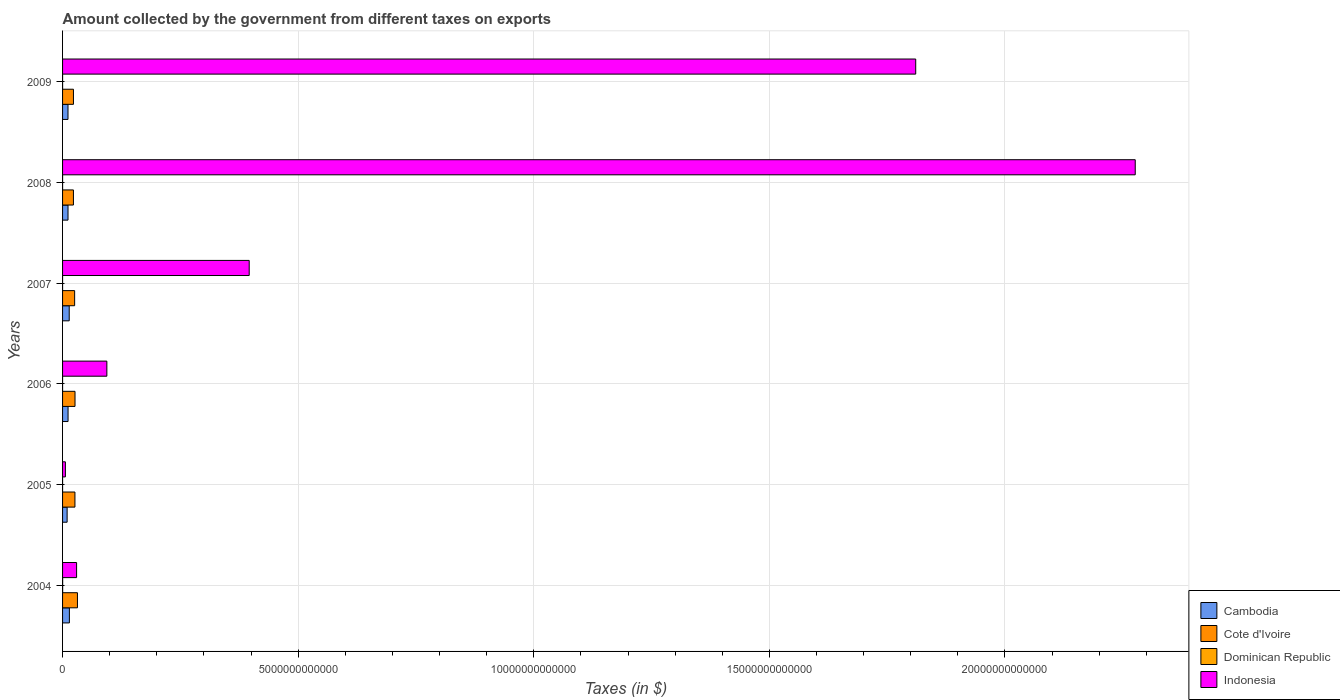Are the number of bars on each tick of the Y-axis equal?
Ensure brevity in your answer.  Yes. What is the amount collected by the government from taxes on exports in Indonesia in 2009?
Your answer should be very brief. 1.81e+13. Across all years, what is the maximum amount collected by the government from taxes on exports in Cambodia?
Your answer should be very brief. 1.45e+11. Across all years, what is the minimum amount collected by the government from taxes on exports in Dominican Republic?
Your answer should be compact. 1.36e+07. In which year was the amount collected by the government from taxes on exports in Cambodia maximum?
Make the answer very short. 2004. In which year was the amount collected by the government from taxes on exports in Dominican Republic minimum?
Make the answer very short. 2005. What is the total amount collected by the government from taxes on exports in Indonesia in the graph?
Offer a terse response. 4.61e+13. What is the difference between the amount collected by the government from taxes on exports in Cote d'Ivoire in 2004 and that in 2006?
Your answer should be very brief. 5.17e+1. What is the difference between the amount collected by the government from taxes on exports in Cote d'Ivoire in 2006 and the amount collected by the government from taxes on exports in Indonesia in 2009?
Give a very brief answer. -1.78e+13. What is the average amount collected by the government from taxes on exports in Indonesia per year?
Keep it short and to the point. 7.69e+12. In the year 2006, what is the difference between the amount collected by the government from taxes on exports in Indonesia and amount collected by the government from taxes on exports in Cote d'Ivoire?
Your response must be concise. 6.76e+11. In how many years, is the amount collected by the government from taxes on exports in Cote d'Ivoire greater than 8000000000000 $?
Make the answer very short. 0. What is the ratio of the amount collected by the government from taxes on exports in Indonesia in 2006 to that in 2009?
Your response must be concise. 0.05. Is the amount collected by the government from taxes on exports in Cote d'Ivoire in 2007 less than that in 2009?
Offer a terse response. No. Is the difference between the amount collected by the government from taxes on exports in Indonesia in 2008 and 2009 greater than the difference between the amount collected by the government from taxes on exports in Cote d'Ivoire in 2008 and 2009?
Your response must be concise. Yes. What is the difference between the highest and the second highest amount collected by the government from taxes on exports in Cote d'Ivoire?
Offer a very short reply. 5.17e+1. What is the difference between the highest and the lowest amount collected by the government from taxes on exports in Cote d'Ivoire?
Provide a succinct answer. 8.52e+1. In how many years, is the amount collected by the government from taxes on exports in Cote d'Ivoire greater than the average amount collected by the government from taxes on exports in Cote d'Ivoire taken over all years?
Provide a succinct answer. 3. What does the 4th bar from the top in 2009 represents?
Your answer should be very brief. Cambodia. What does the 3rd bar from the bottom in 2005 represents?
Your answer should be compact. Dominican Republic. How many years are there in the graph?
Your answer should be very brief. 6. What is the difference between two consecutive major ticks on the X-axis?
Your response must be concise. 5.00e+12. Are the values on the major ticks of X-axis written in scientific E-notation?
Your response must be concise. No. Does the graph contain any zero values?
Give a very brief answer. No. Does the graph contain grids?
Offer a terse response. Yes. Where does the legend appear in the graph?
Provide a succinct answer. Bottom right. How many legend labels are there?
Make the answer very short. 4. How are the legend labels stacked?
Keep it short and to the point. Vertical. What is the title of the graph?
Offer a terse response. Amount collected by the government from different taxes on exports. What is the label or title of the X-axis?
Ensure brevity in your answer.  Taxes (in $). What is the label or title of the Y-axis?
Your answer should be very brief. Years. What is the Taxes (in $) in Cambodia in 2004?
Your response must be concise. 1.45e+11. What is the Taxes (in $) in Cote d'Ivoire in 2004?
Offer a terse response. 3.16e+11. What is the Taxes (in $) in Dominican Republic in 2004?
Offer a very short reply. 1.71e+09. What is the Taxes (in $) of Indonesia in 2004?
Your answer should be very brief. 2.98e+11. What is the Taxes (in $) of Cambodia in 2005?
Offer a terse response. 9.67e+1. What is the Taxes (in $) in Cote d'Ivoire in 2005?
Offer a terse response. 2.63e+11. What is the Taxes (in $) of Dominican Republic in 2005?
Make the answer very short. 1.36e+07. What is the Taxes (in $) of Indonesia in 2005?
Provide a succinct answer. 6.00e+1. What is the Taxes (in $) in Cambodia in 2006?
Your response must be concise. 1.17e+11. What is the Taxes (in $) of Cote d'Ivoire in 2006?
Ensure brevity in your answer.  2.64e+11. What is the Taxes (in $) in Dominican Republic in 2006?
Offer a terse response. 6.90e+07. What is the Taxes (in $) of Indonesia in 2006?
Offer a very short reply. 9.40e+11. What is the Taxes (in $) of Cambodia in 2007?
Offer a very short reply. 1.41e+11. What is the Taxes (in $) of Cote d'Ivoire in 2007?
Ensure brevity in your answer.  2.56e+11. What is the Taxes (in $) in Dominican Republic in 2007?
Offer a terse response. 8.25e+07. What is the Taxes (in $) in Indonesia in 2007?
Make the answer very short. 3.96e+12. What is the Taxes (in $) of Cambodia in 2008?
Offer a terse response. 1.16e+11. What is the Taxes (in $) in Cote d'Ivoire in 2008?
Give a very brief answer. 2.31e+11. What is the Taxes (in $) in Dominican Republic in 2008?
Your answer should be very brief. 1.28e+08. What is the Taxes (in $) in Indonesia in 2008?
Offer a terse response. 2.28e+13. What is the Taxes (in $) of Cambodia in 2009?
Your answer should be very brief. 1.15e+11. What is the Taxes (in $) in Cote d'Ivoire in 2009?
Provide a succinct answer. 2.31e+11. What is the Taxes (in $) of Dominican Republic in 2009?
Ensure brevity in your answer.  1.32e+08. What is the Taxes (in $) of Indonesia in 2009?
Ensure brevity in your answer.  1.81e+13. Across all years, what is the maximum Taxes (in $) of Cambodia?
Offer a terse response. 1.45e+11. Across all years, what is the maximum Taxes (in $) of Cote d'Ivoire?
Provide a succinct answer. 3.16e+11. Across all years, what is the maximum Taxes (in $) in Dominican Republic?
Make the answer very short. 1.71e+09. Across all years, what is the maximum Taxes (in $) of Indonesia?
Ensure brevity in your answer.  2.28e+13. Across all years, what is the minimum Taxes (in $) in Cambodia?
Give a very brief answer. 9.67e+1. Across all years, what is the minimum Taxes (in $) of Cote d'Ivoire?
Your response must be concise. 2.31e+11. Across all years, what is the minimum Taxes (in $) of Dominican Republic?
Provide a succinct answer. 1.36e+07. Across all years, what is the minimum Taxes (in $) of Indonesia?
Make the answer very short. 6.00e+1. What is the total Taxes (in $) of Cambodia in the graph?
Provide a short and direct response. 7.30e+11. What is the total Taxes (in $) in Cote d'Ivoire in the graph?
Your answer should be compact. 1.56e+12. What is the total Taxes (in $) in Dominican Republic in the graph?
Keep it short and to the point. 2.13e+09. What is the total Taxes (in $) of Indonesia in the graph?
Your response must be concise. 4.61e+13. What is the difference between the Taxes (in $) of Cambodia in 2004 and that in 2005?
Offer a very short reply. 4.83e+1. What is the difference between the Taxes (in $) of Cote d'Ivoire in 2004 and that in 2005?
Offer a very short reply. 5.33e+1. What is the difference between the Taxes (in $) in Dominican Republic in 2004 and that in 2005?
Your response must be concise. 1.69e+09. What is the difference between the Taxes (in $) in Indonesia in 2004 and that in 2005?
Offer a terse response. 2.38e+11. What is the difference between the Taxes (in $) in Cambodia in 2004 and that in 2006?
Make the answer very short. 2.83e+1. What is the difference between the Taxes (in $) in Cote d'Ivoire in 2004 and that in 2006?
Ensure brevity in your answer.  5.17e+1. What is the difference between the Taxes (in $) of Dominican Republic in 2004 and that in 2006?
Offer a terse response. 1.64e+09. What is the difference between the Taxes (in $) of Indonesia in 2004 and that in 2006?
Offer a very short reply. -6.42e+11. What is the difference between the Taxes (in $) of Cambodia in 2004 and that in 2007?
Your answer should be very brief. 3.83e+09. What is the difference between the Taxes (in $) of Cote d'Ivoire in 2004 and that in 2007?
Make the answer very short. 5.99e+1. What is the difference between the Taxes (in $) of Dominican Republic in 2004 and that in 2007?
Offer a terse response. 1.62e+09. What is the difference between the Taxes (in $) of Indonesia in 2004 and that in 2007?
Your answer should be compact. -3.66e+12. What is the difference between the Taxes (in $) in Cambodia in 2004 and that in 2008?
Offer a terse response. 2.93e+1. What is the difference between the Taxes (in $) in Cote d'Ivoire in 2004 and that in 2008?
Make the answer very short. 8.52e+1. What is the difference between the Taxes (in $) in Dominican Republic in 2004 and that in 2008?
Ensure brevity in your answer.  1.58e+09. What is the difference between the Taxes (in $) of Indonesia in 2004 and that in 2008?
Your response must be concise. -2.25e+13. What is the difference between the Taxes (in $) of Cambodia in 2004 and that in 2009?
Your answer should be very brief. 2.96e+1. What is the difference between the Taxes (in $) of Cote d'Ivoire in 2004 and that in 2009?
Your response must be concise. 8.48e+1. What is the difference between the Taxes (in $) in Dominican Republic in 2004 and that in 2009?
Keep it short and to the point. 1.57e+09. What is the difference between the Taxes (in $) in Indonesia in 2004 and that in 2009?
Offer a very short reply. -1.78e+13. What is the difference between the Taxes (in $) in Cambodia in 2005 and that in 2006?
Keep it short and to the point. -1.99e+1. What is the difference between the Taxes (in $) in Cote d'Ivoire in 2005 and that in 2006?
Ensure brevity in your answer.  -1.60e+09. What is the difference between the Taxes (in $) in Dominican Republic in 2005 and that in 2006?
Your answer should be compact. -5.54e+07. What is the difference between the Taxes (in $) of Indonesia in 2005 and that in 2006?
Your answer should be very brief. -8.80e+11. What is the difference between the Taxes (in $) of Cambodia in 2005 and that in 2007?
Offer a very short reply. -4.44e+1. What is the difference between the Taxes (in $) of Cote d'Ivoire in 2005 and that in 2007?
Provide a succinct answer. 6.60e+09. What is the difference between the Taxes (in $) of Dominican Republic in 2005 and that in 2007?
Offer a terse response. -6.89e+07. What is the difference between the Taxes (in $) of Indonesia in 2005 and that in 2007?
Your response must be concise. -3.90e+12. What is the difference between the Taxes (in $) in Cambodia in 2005 and that in 2008?
Keep it short and to the point. -1.89e+1. What is the difference between the Taxes (in $) of Cote d'Ivoire in 2005 and that in 2008?
Provide a short and direct response. 3.19e+1. What is the difference between the Taxes (in $) of Dominican Republic in 2005 and that in 2008?
Your answer should be very brief. -1.15e+08. What is the difference between the Taxes (in $) of Indonesia in 2005 and that in 2008?
Provide a succinct answer. -2.27e+13. What is the difference between the Taxes (in $) of Cambodia in 2005 and that in 2009?
Keep it short and to the point. -1.86e+1. What is the difference between the Taxes (in $) in Cote d'Ivoire in 2005 and that in 2009?
Ensure brevity in your answer.  3.15e+1. What is the difference between the Taxes (in $) of Dominican Republic in 2005 and that in 2009?
Provide a short and direct response. -1.18e+08. What is the difference between the Taxes (in $) of Indonesia in 2005 and that in 2009?
Give a very brief answer. -1.80e+13. What is the difference between the Taxes (in $) in Cambodia in 2006 and that in 2007?
Ensure brevity in your answer.  -2.45e+1. What is the difference between the Taxes (in $) in Cote d'Ivoire in 2006 and that in 2007?
Keep it short and to the point. 8.20e+09. What is the difference between the Taxes (in $) of Dominican Republic in 2006 and that in 2007?
Keep it short and to the point. -1.35e+07. What is the difference between the Taxes (in $) of Indonesia in 2006 and that in 2007?
Your answer should be compact. -3.02e+12. What is the difference between the Taxes (in $) of Cambodia in 2006 and that in 2008?
Keep it short and to the point. 1.02e+09. What is the difference between the Taxes (in $) in Cote d'Ivoire in 2006 and that in 2008?
Your response must be concise. 3.35e+1. What is the difference between the Taxes (in $) in Dominican Republic in 2006 and that in 2008?
Provide a succinct answer. -5.92e+07. What is the difference between the Taxes (in $) of Indonesia in 2006 and that in 2008?
Make the answer very short. -2.18e+13. What is the difference between the Taxes (in $) in Cambodia in 2006 and that in 2009?
Make the answer very short. 1.31e+09. What is the difference between the Taxes (in $) in Cote d'Ivoire in 2006 and that in 2009?
Provide a succinct answer. 3.31e+1. What is the difference between the Taxes (in $) of Dominican Republic in 2006 and that in 2009?
Offer a very short reply. -6.27e+07. What is the difference between the Taxes (in $) in Indonesia in 2006 and that in 2009?
Your answer should be very brief. -1.72e+13. What is the difference between the Taxes (in $) of Cambodia in 2007 and that in 2008?
Keep it short and to the point. 2.55e+1. What is the difference between the Taxes (in $) of Cote d'Ivoire in 2007 and that in 2008?
Make the answer very short. 2.53e+1. What is the difference between the Taxes (in $) of Dominican Republic in 2007 and that in 2008?
Your answer should be very brief. -4.56e+07. What is the difference between the Taxes (in $) of Indonesia in 2007 and that in 2008?
Give a very brief answer. -1.88e+13. What is the difference between the Taxes (in $) of Cambodia in 2007 and that in 2009?
Give a very brief answer. 2.58e+1. What is the difference between the Taxes (in $) of Cote d'Ivoire in 2007 and that in 2009?
Offer a terse response. 2.49e+1. What is the difference between the Taxes (in $) in Dominican Republic in 2007 and that in 2009?
Your response must be concise. -4.92e+07. What is the difference between the Taxes (in $) in Indonesia in 2007 and that in 2009?
Provide a short and direct response. -1.41e+13. What is the difference between the Taxes (in $) of Cambodia in 2008 and that in 2009?
Give a very brief answer. 2.95e+08. What is the difference between the Taxes (in $) in Cote d'Ivoire in 2008 and that in 2009?
Your answer should be very brief. -4.00e+08. What is the difference between the Taxes (in $) in Dominican Republic in 2008 and that in 2009?
Make the answer very short. -3.52e+06. What is the difference between the Taxes (in $) in Indonesia in 2008 and that in 2009?
Your answer should be very brief. 4.66e+12. What is the difference between the Taxes (in $) in Cambodia in 2004 and the Taxes (in $) in Cote d'Ivoire in 2005?
Provide a succinct answer. -1.18e+11. What is the difference between the Taxes (in $) in Cambodia in 2004 and the Taxes (in $) in Dominican Republic in 2005?
Keep it short and to the point. 1.45e+11. What is the difference between the Taxes (in $) in Cambodia in 2004 and the Taxes (in $) in Indonesia in 2005?
Offer a very short reply. 8.49e+1. What is the difference between the Taxes (in $) in Cote d'Ivoire in 2004 and the Taxes (in $) in Dominican Republic in 2005?
Keep it short and to the point. 3.16e+11. What is the difference between the Taxes (in $) in Cote d'Ivoire in 2004 and the Taxes (in $) in Indonesia in 2005?
Offer a very short reply. 2.56e+11. What is the difference between the Taxes (in $) in Dominican Republic in 2004 and the Taxes (in $) in Indonesia in 2005?
Offer a very short reply. -5.83e+1. What is the difference between the Taxes (in $) of Cambodia in 2004 and the Taxes (in $) of Cote d'Ivoire in 2006?
Your answer should be very brief. -1.19e+11. What is the difference between the Taxes (in $) of Cambodia in 2004 and the Taxes (in $) of Dominican Republic in 2006?
Your response must be concise. 1.45e+11. What is the difference between the Taxes (in $) in Cambodia in 2004 and the Taxes (in $) in Indonesia in 2006?
Ensure brevity in your answer.  -7.95e+11. What is the difference between the Taxes (in $) in Cote d'Ivoire in 2004 and the Taxes (in $) in Dominican Republic in 2006?
Offer a terse response. 3.16e+11. What is the difference between the Taxes (in $) in Cote d'Ivoire in 2004 and the Taxes (in $) in Indonesia in 2006?
Your answer should be compact. -6.24e+11. What is the difference between the Taxes (in $) of Dominican Republic in 2004 and the Taxes (in $) of Indonesia in 2006?
Your response must be concise. -9.38e+11. What is the difference between the Taxes (in $) in Cambodia in 2004 and the Taxes (in $) in Cote d'Ivoire in 2007?
Ensure brevity in your answer.  -1.11e+11. What is the difference between the Taxes (in $) of Cambodia in 2004 and the Taxes (in $) of Dominican Republic in 2007?
Your answer should be compact. 1.45e+11. What is the difference between the Taxes (in $) in Cambodia in 2004 and the Taxes (in $) in Indonesia in 2007?
Offer a very short reply. -3.82e+12. What is the difference between the Taxes (in $) in Cote d'Ivoire in 2004 and the Taxes (in $) in Dominican Republic in 2007?
Keep it short and to the point. 3.16e+11. What is the difference between the Taxes (in $) in Cote d'Ivoire in 2004 and the Taxes (in $) in Indonesia in 2007?
Ensure brevity in your answer.  -3.64e+12. What is the difference between the Taxes (in $) of Dominican Republic in 2004 and the Taxes (in $) of Indonesia in 2007?
Provide a succinct answer. -3.96e+12. What is the difference between the Taxes (in $) of Cambodia in 2004 and the Taxes (in $) of Cote d'Ivoire in 2008?
Your response must be concise. -8.59e+1. What is the difference between the Taxes (in $) of Cambodia in 2004 and the Taxes (in $) of Dominican Republic in 2008?
Your answer should be compact. 1.45e+11. What is the difference between the Taxes (in $) of Cambodia in 2004 and the Taxes (in $) of Indonesia in 2008?
Offer a terse response. -2.26e+13. What is the difference between the Taxes (in $) of Cote d'Ivoire in 2004 and the Taxes (in $) of Dominican Republic in 2008?
Make the answer very short. 3.16e+11. What is the difference between the Taxes (in $) of Cote d'Ivoire in 2004 and the Taxes (in $) of Indonesia in 2008?
Provide a succinct answer. -2.24e+13. What is the difference between the Taxes (in $) of Dominican Republic in 2004 and the Taxes (in $) of Indonesia in 2008?
Your answer should be very brief. -2.28e+13. What is the difference between the Taxes (in $) in Cambodia in 2004 and the Taxes (in $) in Cote d'Ivoire in 2009?
Give a very brief answer. -8.63e+1. What is the difference between the Taxes (in $) of Cambodia in 2004 and the Taxes (in $) of Dominican Republic in 2009?
Make the answer very short. 1.45e+11. What is the difference between the Taxes (in $) of Cambodia in 2004 and the Taxes (in $) of Indonesia in 2009?
Keep it short and to the point. -1.80e+13. What is the difference between the Taxes (in $) in Cote d'Ivoire in 2004 and the Taxes (in $) in Dominican Republic in 2009?
Your response must be concise. 3.16e+11. What is the difference between the Taxes (in $) of Cote d'Ivoire in 2004 and the Taxes (in $) of Indonesia in 2009?
Ensure brevity in your answer.  -1.78e+13. What is the difference between the Taxes (in $) of Dominican Republic in 2004 and the Taxes (in $) of Indonesia in 2009?
Provide a succinct answer. -1.81e+13. What is the difference between the Taxes (in $) of Cambodia in 2005 and the Taxes (in $) of Cote d'Ivoire in 2006?
Your answer should be very brief. -1.68e+11. What is the difference between the Taxes (in $) in Cambodia in 2005 and the Taxes (in $) in Dominican Republic in 2006?
Give a very brief answer. 9.66e+1. What is the difference between the Taxes (in $) in Cambodia in 2005 and the Taxes (in $) in Indonesia in 2006?
Your answer should be compact. -8.43e+11. What is the difference between the Taxes (in $) in Cote d'Ivoire in 2005 and the Taxes (in $) in Dominican Republic in 2006?
Give a very brief answer. 2.63e+11. What is the difference between the Taxes (in $) of Cote d'Ivoire in 2005 and the Taxes (in $) of Indonesia in 2006?
Offer a very short reply. -6.77e+11. What is the difference between the Taxes (in $) of Dominican Republic in 2005 and the Taxes (in $) of Indonesia in 2006?
Keep it short and to the point. -9.40e+11. What is the difference between the Taxes (in $) in Cambodia in 2005 and the Taxes (in $) in Cote d'Ivoire in 2007?
Make the answer very short. -1.59e+11. What is the difference between the Taxes (in $) in Cambodia in 2005 and the Taxes (in $) in Dominican Republic in 2007?
Provide a short and direct response. 9.66e+1. What is the difference between the Taxes (in $) of Cambodia in 2005 and the Taxes (in $) of Indonesia in 2007?
Provide a succinct answer. -3.86e+12. What is the difference between the Taxes (in $) in Cote d'Ivoire in 2005 and the Taxes (in $) in Dominican Republic in 2007?
Provide a short and direct response. 2.63e+11. What is the difference between the Taxes (in $) in Cote d'Ivoire in 2005 and the Taxes (in $) in Indonesia in 2007?
Your answer should be very brief. -3.70e+12. What is the difference between the Taxes (in $) in Dominican Republic in 2005 and the Taxes (in $) in Indonesia in 2007?
Offer a very short reply. -3.96e+12. What is the difference between the Taxes (in $) of Cambodia in 2005 and the Taxes (in $) of Cote d'Ivoire in 2008?
Your answer should be very brief. -1.34e+11. What is the difference between the Taxes (in $) of Cambodia in 2005 and the Taxes (in $) of Dominican Republic in 2008?
Offer a very short reply. 9.66e+1. What is the difference between the Taxes (in $) of Cambodia in 2005 and the Taxes (in $) of Indonesia in 2008?
Make the answer very short. -2.27e+13. What is the difference between the Taxes (in $) of Cote d'Ivoire in 2005 and the Taxes (in $) of Dominican Republic in 2008?
Keep it short and to the point. 2.63e+11. What is the difference between the Taxes (in $) in Cote d'Ivoire in 2005 and the Taxes (in $) in Indonesia in 2008?
Keep it short and to the point. -2.25e+13. What is the difference between the Taxes (in $) in Dominican Republic in 2005 and the Taxes (in $) in Indonesia in 2008?
Provide a short and direct response. -2.28e+13. What is the difference between the Taxes (in $) of Cambodia in 2005 and the Taxes (in $) of Cote d'Ivoire in 2009?
Keep it short and to the point. -1.35e+11. What is the difference between the Taxes (in $) in Cambodia in 2005 and the Taxes (in $) in Dominican Republic in 2009?
Offer a terse response. 9.66e+1. What is the difference between the Taxes (in $) in Cambodia in 2005 and the Taxes (in $) in Indonesia in 2009?
Give a very brief answer. -1.80e+13. What is the difference between the Taxes (in $) of Cote d'Ivoire in 2005 and the Taxes (in $) of Dominican Republic in 2009?
Make the answer very short. 2.63e+11. What is the difference between the Taxes (in $) of Cote d'Ivoire in 2005 and the Taxes (in $) of Indonesia in 2009?
Give a very brief answer. -1.78e+13. What is the difference between the Taxes (in $) of Dominican Republic in 2005 and the Taxes (in $) of Indonesia in 2009?
Your response must be concise. -1.81e+13. What is the difference between the Taxes (in $) of Cambodia in 2006 and the Taxes (in $) of Cote d'Ivoire in 2007?
Make the answer very short. -1.39e+11. What is the difference between the Taxes (in $) in Cambodia in 2006 and the Taxes (in $) in Dominican Republic in 2007?
Make the answer very short. 1.17e+11. What is the difference between the Taxes (in $) in Cambodia in 2006 and the Taxes (in $) in Indonesia in 2007?
Ensure brevity in your answer.  -3.84e+12. What is the difference between the Taxes (in $) of Cote d'Ivoire in 2006 and the Taxes (in $) of Dominican Republic in 2007?
Provide a succinct answer. 2.64e+11. What is the difference between the Taxes (in $) of Cote d'Ivoire in 2006 and the Taxes (in $) of Indonesia in 2007?
Provide a short and direct response. -3.70e+12. What is the difference between the Taxes (in $) of Dominican Republic in 2006 and the Taxes (in $) of Indonesia in 2007?
Offer a very short reply. -3.96e+12. What is the difference between the Taxes (in $) of Cambodia in 2006 and the Taxes (in $) of Cote d'Ivoire in 2008?
Your response must be concise. -1.14e+11. What is the difference between the Taxes (in $) of Cambodia in 2006 and the Taxes (in $) of Dominican Republic in 2008?
Your answer should be very brief. 1.17e+11. What is the difference between the Taxes (in $) in Cambodia in 2006 and the Taxes (in $) in Indonesia in 2008?
Keep it short and to the point. -2.26e+13. What is the difference between the Taxes (in $) in Cote d'Ivoire in 2006 and the Taxes (in $) in Dominican Republic in 2008?
Offer a terse response. 2.64e+11. What is the difference between the Taxes (in $) in Cote d'Ivoire in 2006 and the Taxes (in $) in Indonesia in 2008?
Give a very brief answer. -2.25e+13. What is the difference between the Taxes (in $) of Dominican Republic in 2006 and the Taxes (in $) of Indonesia in 2008?
Provide a succinct answer. -2.28e+13. What is the difference between the Taxes (in $) in Cambodia in 2006 and the Taxes (in $) in Cote d'Ivoire in 2009?
Your answer should be very brief. -1.15e+11. What is the difference between the Taxes (in $) of Cambodia in 2006 and the Taxes (in $) of Dominican Republic in 2009?
Ensure brevity in your answer.  1.17e+11. What is the difference between the Taxes (in $) in Cambodia in 2006 and the Taxes (in $) in Indonesia in 2009?
Your answer should be very brief. -1.80e+13. What is the difference between the Taxes (in $) in Cote d'Ivoire in 2006 and the Taxes (in $) in Dominican Republic in 2009?
Ensure brevity in your answer.  2.64e+11. What is the difference between the Taxes (in $) in Cote d'Ivoire in 2006 and the Taxes (in $) in Indonesia in 2009?
Your answer should be compact. -1.78e+13. What is the difference between the Taxes (in $) of Dominican Republic in 2006 and the Taxes (in $) of Indonesia in 2009?
Make the answer very short. -1.81e+13. What is the difference between the Taxes (in $) of Cambodia in 2007 and the Taxes (in $) of Cote d'Ivoire in 2008?
Offer a terse response. -8.97e+1. What is the difference between the Taxes (in $) of Cambodia in 2007 and the Taxes (in $) of Dominican Republic in 2008?
Offer a very short reply. 1.41e+11. What is the difference between the Taxes (in $) of Cambodia in 2007 and the Taxes (in $) of Indonesia in 2008?
Provide a short and direct response. -2.26e+13. What is the difference between the Taxes (in $) of Cote d'Ivoire in 2007 and the Taxes (in $) of Dominican Republic in 2008?
Ensure brevity in your answer.  2.56e+11. What is the difference between the Taxes (in $) of Cote d'Ivoire in 2007 and the Taxes (in $) of Indonesia in 2008?
Make the answer very short. -2.25e+13. What is the difference between the Taxes (in $) of Dominican Republic in 2007 and the Taxes (in $) of Indonesia in 2008?
Your response must be concise. -2.28e+13. What is the difference between the Taxes (in $) of Cambodia in 2007 and the Taxes (in $) of Cote d'Ivoire in 2009?
Make the answer very short. -9.01e+1. What is the difference between the Taxes (in $) in Cambodia in 2007 and the Taxes (in $) in Dominican Republic in 2009?
Your answer should be compact. 1.41e+11. What is the difference between the Taxes (in $) in Cambodia in 2007 and the Taxes (in $) in Indonesia in 2009?
Provide a short and direct response. -1.80e+13. What is the difference between the Taxes (in $) of Cote d'Ivoire in 2007 and the Taxes (in $) of Dominican Republic in 2009?
Provide a short and direct response. 2.56e+11. What is the difference between the Taxes (in $) in Cote d'Ivoire in 2007 and the Taxes (in $) in Indonesia in 2009?
Make the answer very short. -1.78e+13. What is the difference between the Taxes (in $) in Dominican Republic in 2007 and the Taxes (in $) in Indonesia in 2009?
Offer a terse response. -1.81e+13. What is the difference between the Taxes (in $) in Cambodia in 2008 and the Taxes (in $) in Cote d'Ivoire in 2009?
Provide a short and direct response. -1.16e+11. What is the difference between the Taxes (in $) of Cambodia in 2008 and the Taxes (in $) of Dominican Republic in 2009?
Make the answer very short. 1.15e+11. What is the difference between the Taxes (in $) in Cambodia in 2008 and the Taxes (in $) in Indonesia in 2009?
Provide a succinct answer. -1.80e+13. What is the difference between the Taxes (in $) in Cote d'Ivoire in 2008 and the Taxes (in $) in Dominican Republic in 2009?
Your answer should be compact. 2.31e+11. What is the difference between the Taxes (in $) of Cote d'Ivoire in 2008 and the Taxes (in $) of Indonesia in 2009?
Your answer should be very brief. -1.79e+13. What is the difference between the Taxes (in $) of Dominican Republic in 2008 and the Taxes (in $) of Indonesia in 2009?
Provide a succinct answer. -1.81e+13. What is the average Taxes (in $) of Cambodia per year?
Your response must be concise. 1.22e+11. What is the average Taxes (in $) in Cote d'Ivoire per year?
Offer a very short reply. 2.60e+11. What is the average Taxes (in $) of Dominican Republic per year?
Offer a very short reply. 3.55e+08. What is the average Taxes (in $) of Indonesia per year?
Offer a terse response. 7.69e+12. In the year 2004, what is the difference between the Taxes (in $) of Cambodia and Taxes (in $) of Cote d'Ivoire?
Offer a very short reply. -1.71e+11. In the year 2004, what is the difference between the Taxes (in $) of Cambodia and Taxes (in $) of Dominican Republic?
Give a very brief answer. 1.43e+11. In the year 2004, what is the difference between the Taxes (in $) in Cambodia and Taxes (in $) in Indonesia?
Your answer should be compact. -1.53e+11. In the year 2004, what is the difference between the Taxes (in $) in Cote d'Ivoire and Taxes (in $) in Dominican Republic?
Your answer should be compact. 3.14e+11. In the year 2004, what is the difference between the Taxes (in $) of Cote d'Ivoire and Taxes (in $) of Indonesia?
Your response must be concise. 1.82e+1. In the year 2004, what is the difference between the Taxes (in $) of Dominican Republic and Taxes (in $) of Indonesia?
Make the answer very short. -2.96e+11. In the year 2005, what is the difference between the Taxes (in $) of Cambodia and Taxes (in $) of Cote d'Ivoire?
Provide a succinct answer. -1.66e+11. In the year 2005, what is the difference between the Taxes (in $) in Cambodia and Taxes (in $) in Dominican Republic?
Your response must be concise. 9.67e+1. In the year 2005, what is the difference between the Taxes (in $) of Cambodia and Taxes (in $) of Indonesia?
Ensure brevity in your answer.  3.67e+1. In the year 2005, what is the difference between the Taxes (in $) of Cote d'Ivoire and Taxes (in $) of Dominican Republic?
Your response must be concise. 2.63e+11. In the year 2005, what is the difference between the Taxes (in $) of Cote d'Ivoire and Taxes (in $) of Indonesia?
Keep it short and to the point. 2.03e+11. In the year 2005, what is the difference between the Taxes (in $) of Dominican Republic and Taxes (in $) of Indonesia?
Your response must be concise. -6.00e+1. In the year 2006, what is the difference between the Taxes (in $) of Cambodia and Taxes (in $) of Cote d'Ivoire?
Offer a very short reply. -1.48e+11. In the year 2006, what is the difference between the Taxes (in $) in Cambodia and Taxes (in $) in Dominican Republic?
Provide a short and direct response. 1.17e+11. In the year 2006, what is the difference between the Taxes (in $) of Cambodia and Taxes (in $) of Indonesia?
Your answer should be very brief. -8.23e+11. In the year 2006, what is the difference between the Taxes (in $) in Cote d'Ivoire and Taxes (in $) in Dominican Republic?
Your response must be concise. 2.64e+11. In the year 2006, what is the difference between the Taxes (in $) in Cote d'Ivoire and Taxes (in $) in Indonesia?
Ensure brevity in your answer.  -6.76e+11. In the year 2006, what is the difference between the Taxes (in $) in Dominican Republic and Taxes (in $) in Indonesia?
Offer a very short reply. -9.40e+11. In the year 2007, what is the difference between the Taxes (in $) of Cambodia and Taxes (in $) of Cote d'Ivoire?
Keep it short and to the point. -1.15e+11. In the year 2007, what is the difference between the Taxes (in $) of Cambodia and Taxes (in $) of Dominican Republic?
Make the answer very short. 1.41e+11. In the year 2007, what is the difference between the Taxes (in $) of Cambodia and Taxes (in $) of Indonesia?
Ensure brevity in your answer.  -3.82e+12. In the year 2007, what is the difference between the Taxes (in $) of Cote d'Ivoire and Taxes (in $) of Dominican Republic?
Make the answer very short. 2.56e+11. In the year 2007, what is the difference between the Taxes (in $) of Cote d'Ivoire and Taxes (in $) of Indonesia?
Provide a succinct answer. -3.70e+12. In the year 2007, what is the difference between the Taxes (in $) in Dominican Republic and Taxes (in $) in Indonesia?
Ensure brevity in your answer.  -3.96e+12. In the year 2008, what is the difference between the Taxes (in $) in Cambodia and Taxes (in $) in Cote d'Ivoire?
Your response must be concise. -1.15e+11. In the year 2008, what is the difference between the Taxes (in $) in Cambodia and Taxes (in $) in Dominican Republic?
Keep it short and to the point. 1.15e+11. In the year 2008, what is the difference between the Taxes (in $) of Cambodia and Taxes (in $) of Indonesia?
Make the answer very short. -2.26e+13. In the year 2008, what is the difference between the Taxes (in $) in Cote d'Ivoire and Taxes (in $) in Dominican Republic?
Ensure brevity in your answer.  2.31e+11. In the year 2008, what is the difference between the Taxes (in $) in Cote d'Ivoire and Taxes (in $) in Indonesia?
Provide a succinct answer. -2.25e+13. In the year 2008, what is the difference between the Taxes (in $) of Dominican Republic and Taxes (in $) of Indonesia?
Give a very brief answer. -2.28e+13. In the year 2009, what is the difference between the Taxes (in $) in Cambodia and Taxes (in $) in Cote d'Ivoire?
Offer a terse response. -1.16e+11. In the year 2009, what is the difference between the Taxes (in $) of Cambodia and Taxes (in $) of Dominican Republic?
Give a very brief answer. 1.15e+11. In the year 2009, what is the difference between the Taxes (in $) in Cambodia and Taxes (in $) in Indonesia?
Offer a terse response. -1.80e+13. In the year 2009, what is the difference between the Taxes (in $) of Cote d'Ivoire and Taxes (in $) of Dominican Republic?
Ensure brevity in your answer.  2.31e+11. In the year 2009, what is the difference between the Taxes (in $) in Cote d'Ivoire and Taxes (in $) in Indonesia?
Keep it short and to the point. -1.79e+13. In the year 2009, what is the difference between the Taxes (in $) of Dominican Republic and Taxes (in $) of Indonesia?
Give a very brief answer. -1.81e+13. What is the ratio of the Taxes (in $) in Cambodia in 2004 to that in 2005?
Provide a short and direct response. 1.5. What is the ratio of the Taxes (in $) in Cote d'Ivoire in 2004 to that in 2005?
Keep it short and to the point. 1.2. What is the ratio of the Taxes (in $) of Dominican Republic in 2004 to that in 2005?
Provide a short and direct response. 125.75. What is the ratio of the Taxes (in $) in Indonesia in 2004 to that in 2005?
Ensure brevity in your answer.  4.96. What is the ratio of the Taxes (in $) of Cambodia in 2004 to that in 2006?
Give a very brief answer. 1.24. What is the ratio of the Taxes (in $) of Cote d'Ivoire in 2004 to that in 2006?
Offer a very short reply. 1.2. What is the ratio of the Taxes (in $) of Dominican Republic in 2004 to that in 2006?
Provide a succinct answer. 24.73. What is the ratio of the Taxes (in $) of Indonesia in 2004 to that in 2006?
Provide a short and direct response. 0.32. What is the ratio of the Taxes (in $) in Cambodia in 2004 to that in 2007?
Offer a terse response. 1.03. What is the ratio of the Taxes (in $) of Cote d'Ivoire in 2004 to that in 2007?
Offer a terse response. 1.23. What is the ratio of the Taxes (in $) in Dominican Republic in 2004 to that in 2007?
Offer a very short reply. 20.68. What is the ratio of the Taxes (in $) in Indonesia in 2004 to that in 2007?
Provide a succinct answer. 0.08. What is the ratio of the Taxes (in $) in Cambodia in 2004 to that in 2008?
Your response must be concise. 1.25. What is the ratio of the Taxes (in $) of Cote d'Ivoire in 2004 to that in 2008?
Your response must be concise. 1.37. What is the ratio of the Taxes (in $) of Dominican Republic in 2004 to that in 2008?
Your response must be concise. 13.31. What is the ratio of the Taxes (in $) in Indonesia in 2004 to that in 2008?
Ensure brevity in your answer.  0.01. What is the ratio of the Taxes (in $) of Cambodia in 2004 to that in 2009?
Keep it short and to the point. 1.26. What is the ratio of the Taxes (in $) of Cote d'Ivoire in 2004 to that in 2009?
Provide a short and direct response. 1.37. What is the ratio of the Taxes (in $) in Dominican Republic in 2004 to that in 2009?
Offer a very short reply. 12.96. What is the ratio of the Taxes (in $) of Indonesia in 2004 to that in 2009?
Ensure brevity in your answer.  0.02. What is the ratio of the Taxes (in $) in Cambodia in 2005 to that in 2006?
Your response must be concise. 0.83. What is the ratio of the Taxes (in $) of Dominican Republic in 2005 to that in 2006?
Offer a terse response. 0.2. What is the ratio of the Taxes (in $) in Indonesia in 2005 to that in 2006?
Your answer should be very brief. 0.06. What is the ratio of the Taxes (in $) of Cambodia in 2005 to that in 2007?
Keep it short and to the point. 0.69. What is the ratio of the Taxes (in $) of Cote d'Ivoire in 2005 to that in 2007?
Keep it short and to the point. 1.03. What is the ratio of the Taxes (in $) in Dominican Republic in 2005 to that in 2007?
Your answer should be compact. 0.16. What is the ratio of the Taxes (in $) of Indonesia in 2005 to that in 2007?
Keep it short and to the point. 0.02. What is the ratio of the Taxes (in $) in Cambodia in 2005 to that in 2008?
Make the answer very short. 0.84. What is the ratio of the Taxes (in $) of Cote d'Ivoire in 2005 to that in 2008?
Provide a succinct answer. 1.14. What is the ratio of the Taxes (in $) of Dominican Republic in 2005 to that in 2008?
Your answer should be compact. 0.11. What is the ratio of the Taxes (in $) in Indonesia in 2005 to that in 2008?
Your answer should be very brief. 0. What is the ratio of the Taxes (in $) in Cambodia in 2005 to that in 2009?
Your answer should be very brief. 0.84. What is the ratio of the Taxes (in $) in Cote d'Ivoire in 2005 to that in 2009?
Ensure brevity in your answer.  1.14. What is the ratio of the Taxes (in $) of Dominican Republic in 2005 to that in 2009?
Offer a very short reply. 0.1. What is the ratio of the Taxes (in $) in Indonesia in 2005 to that in 2009?
Provide a succinct answer. 0. What is the ratio of the Taxes (in $) of Cambodia in 2006 to that in 2007?
Make the answer very short. 0.83. What is the ratio of the Taxes (in $) of Cote d'Ivoire in 2006 to that in 2007?
Your answer should be very brief. 1.03. What is the ratio of the Taxes (in $) in Dominican Republic in 2006 to that in 2007?
Provide a succinct answer. 0.84. What is the ratio of the Taxes (in $) of Indonesia in 2006 to that in 2007?
Give a very brief answer. 0.24. What is the ratio of the Taxes (in $) of Cambodia in 2006 to that in 2008?
Ensure brevity in your answer.  1.01. What is the ratio of the Taxes (in $) of Cote d'Ivoire in 2006 to that in 2008?
Provide a succinct answer. 1.15. What is the ratio of the Taxes (in $) in Dominican Republic in 2006 to that in 2008?
Make the answer very short. 0.54. What is the ratio of the Taxes (in $) in Indonesia in 2006 to that in 2008?
Make the answer very short. 0.04. What is the ratio of the Taxes (in $) in Cambodia in 2006 to that in 2009?
Offer a very short reply. 1.01. What is the ratio of the Taxes (in $) in Cote d'Ivoire in 2006 to that in 2009?
Provide a succinct answer. 1.14. What is the ratio of the Taxes (in $) of Dominican Republic in 2006 to that in 2009?
Give a very brief answer. 0.52. What is the ratio of the Taxes (in $) in Indonesia in 2006 to that in 2009?
Offer a very short reply. 0.05. What is the ratio of the Taxes (in $) of Cambodia in 2007 to that in 2008?
Offer a terse response. 1.22. What is the ratio of the Taxes (in $) in Cote d'Ivoire in 2007 to that in 2008?
Your answer should be very brief. 1.11. What is the ratio of the Taxes (in $) in Dominican Republic in 2007 to that in 2008?
Make the answer very short. 0.64. What is the ratio of the Taxes (in $) of Indonesia in 2007 to that in 2008?
Give a very brief answer. 0.17. What is the ratio of the Taxes (in $) of Cambodia in 2007 to that in 2009?
Your answer should be compact. 1.22. What is the ratio of the Taxes (in $) in Cote d'Ivoire in 2007 to that in 2009?
Provide a succinct answer. 1.11. What is the ratio of the Taxes (in $) in Dominican Republic in 2007 to that in 2009?
Provide a succinct answer. 0.63. What is the ratio of the Taxes (in $) of Indonesia in 2007 to that in 2009?
Offer a very short reply. 0.22. What is the ratio of the Taxes (in $) in Cambodia in 2008 to that in 2009?
Offer a very short reply. 1. What is the ratio of the Taxes (in $) in Cote d'Ivoire in 2008 to that in 2009?
Give a very brief answer. 1. What is the ratio of the Taxes (in $) of Dominican Republic in 2008 to that in 2009?
Offer a terse response. 0.97. What is the ratio of the Taxes (in $) of Indonesia in 2008 to that in 2009?
Provide a short and direct response. 1.26. What is the difference between the highest and the second highest Taxes (in $) in Cambodia?
Make the answer very short. 3.83e+09. What is the difference between the highest and the second highest Taxes (in $) of Cote d'Ivoire?
Keep it short and to the point. 5.17e+1. What is the difference between the highest and the second highest Taxes (in $) in Dominican Republic?
Keep it short and to the point. 1.57e+09. What is the difference between the highest and the second highest Taxes (in $) in Indonesia?
Provide a short and direct response. 4.66e+12. What is the difference between the highest and the lowest Taxes (in $) in Cambodia?
Give a very brief answer. 4.83e+1. What is the difference between the highest and the lowest Taxes (in $) of Cote d'Ivoire?
Your response must be concise. 8.52e+1. What is the difference between the highest and the lowest Taxes (in $) in Dominican Republic?
Provide a succinct answer. 1.69e+09. What is the difference between the highest and the lowest Taxes (in $) of Indonesia?
Your answer should be compact. 2.27e+13. 